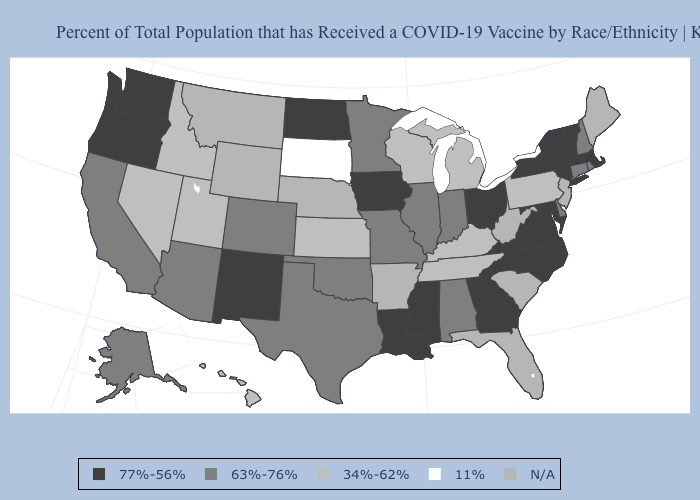Among the states that border Washington , which have the lowest value?
Concise answer only. Idaho. Among the states that border New Mexico , which have the highest value?
Be succinct. Arizona, Colorado, Oklahoma, Texas. Which states have the lowest value in the USA?
Be succinct. South Dakota. Which states hav the highest value in the Northeast?
Short answer required. Massachusetts, New York, Vermont. What is the highest value in the Northeast ?
Write a very short answer. 77%-56%. Does Utah have the highest value in the West?
Give a very brief answer. No. What is the lowest value in the South?
Quick response, please. 34%-62%. Does the first symbol in the legend represent the smallest category?
Give a very brief answer. No. What is the value of Pennsylvania?
Write a very short answer. 34%-62%. How many symbols are there in the legend?
Give a very brief answer. 5. Which states hav the highest value in the South?
Be succinct. Georgia, Louisiana, Maryland, Mississippi, North Carolina, Virginia. Among the states that border New Jersey , does Delaware have the lowest value?
Short answer required. No. 